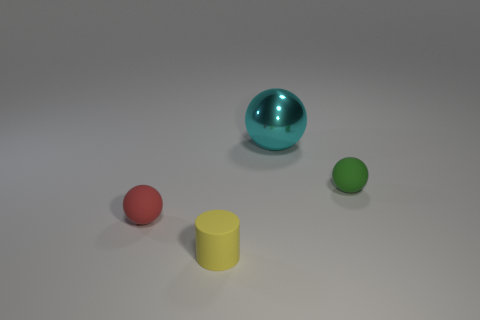Add 2 green matte balls. How many objects exist? 6 Subtract all cyan spheres. How many spheres are left? 2 Subtract all red balls. How many balls are left? 2 Subtract all spheres. How many objects are left? 1 Subtract all gray cylinders. Subtract all brown cubes. How many cylinders are left? 1 Subtract all small things. Subtract all large cyan objects. How many objects are left? 0 Add 3 small red balls. How many small red balls are left? 4 Add 3 red shiny cubes. How many red shiny cubes exist? 3 Subtract 0 red cylinders. How many objects are left? 4 